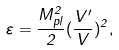<formula> <loc_0><loc_0><loc_500><loc_500>\varepsilon = \frac { M _ { p l } ^ { 2 } } { 2 } ( \frac { V ^ { \prime } } { V } ) ^ { 2 } ,</formula> 